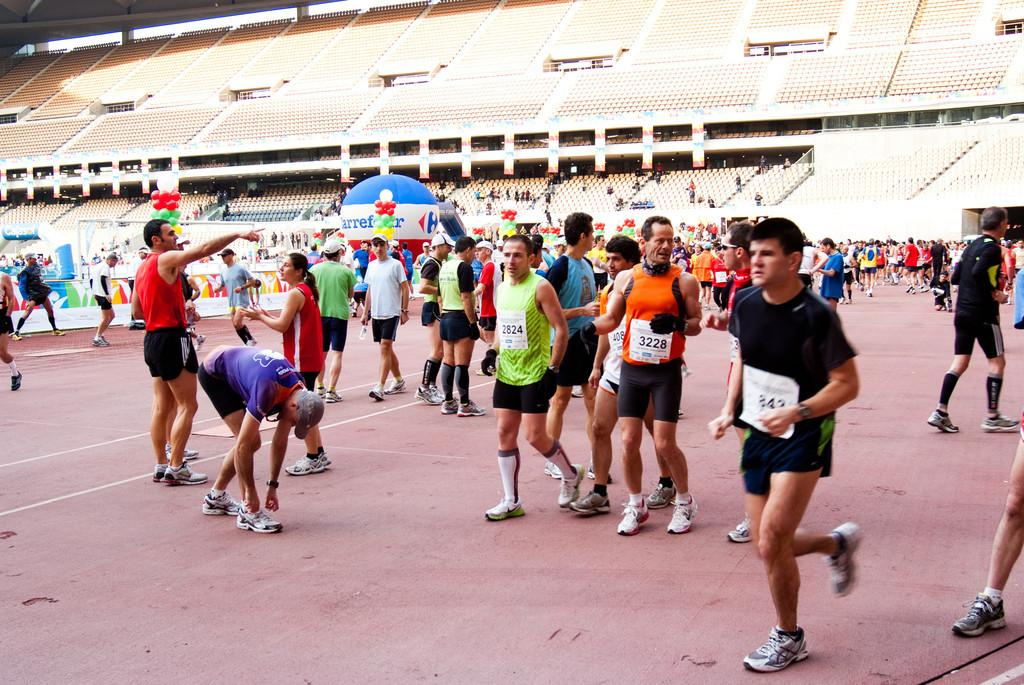How many people are in the image? There is a group of people in the image, but the exact number is not specified. What are the people doing in the image? The people are on the ground, but their specific activity is not described. What can be seen in the background of the image? There is a shed in the background of the image. What type of acoustics can be heard from the shed in the image? There is no information about the acoustics or any sounds coming from the shed in the image. Is there a store located near the shed in the image? The image does not provide any information about a store or its location in relation to the shed. 